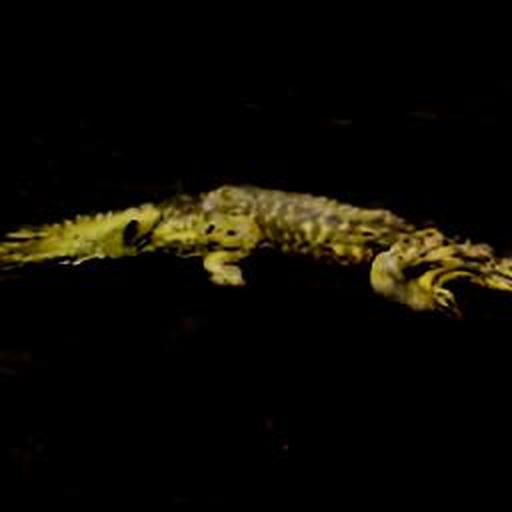What kind of environment do crocodiles typically live in? Crocodiles typically inhabit freshwater environments such as rivers, lakes, wetlands, and sometimes brackish water. They require a habitat that provides ample sunlight, water for submersion, and a food supply of fish, birds, and mammals. Is this a common way to see a crocodile, as shown in the image? Yes, crocodiles are often seen partially submerged in water like this, as it allows them to regulate their body temperature, stay hydrated, and ambush prey. However, this image doesn't depict the creature's behavior clearly due to the lighting and quality issues. 